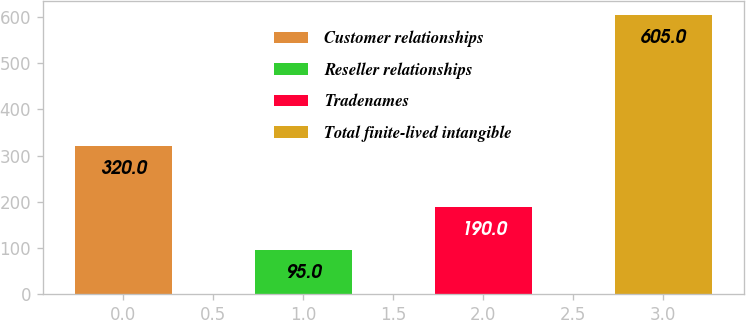Convert chart. <chart><loc_0><loc_0><loc_500><loc_500><bar_chart><fcel>Customer relationships<fcel>Reseller relationships<fcel>Tradenames<fcel>Total finite-lived intangible<nl><fcel>320<fcel>95<fcel>190<fcel>605<nl></chart> 